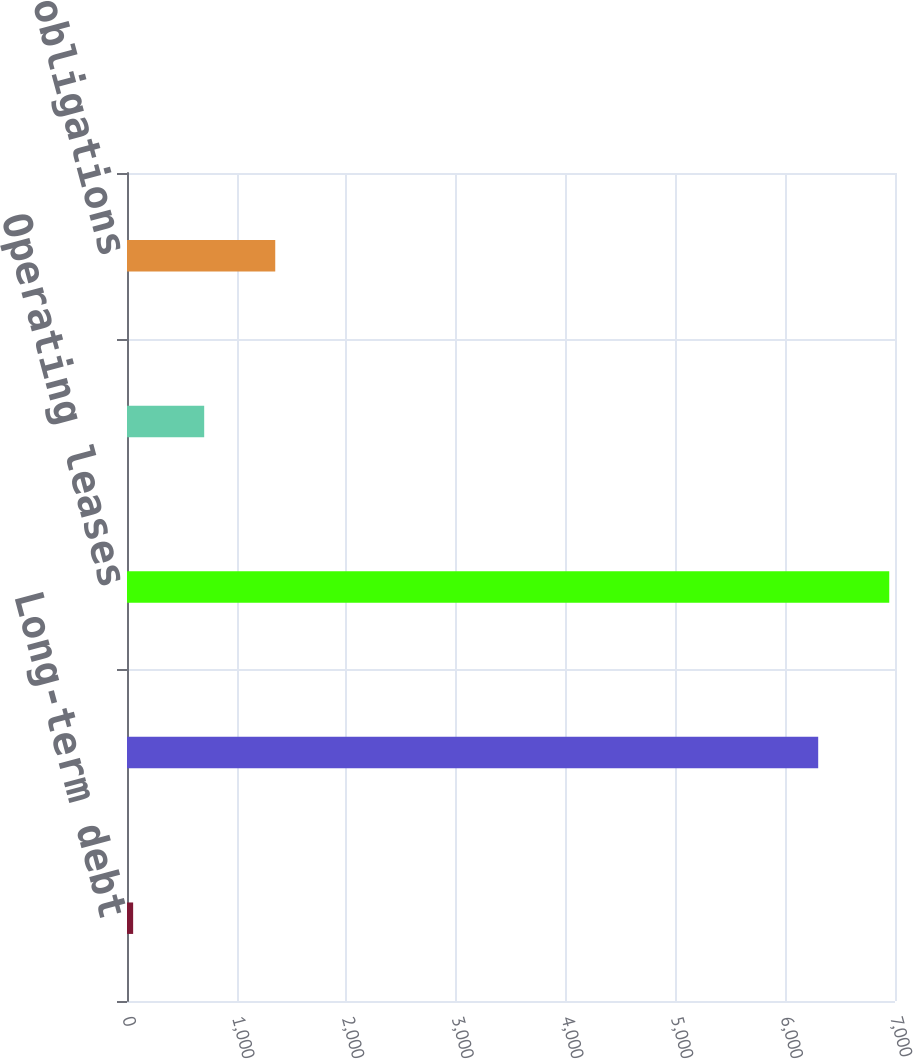Convert chart to OTSL. <chart><loc_0><loc_0><loc_500><loc_500><bar_chart><fcel>Long-term debt<fcel>Interest on long-term debt<fcel>Operating leases<fcel>Licensing rights<fcel>Post-retirement obligations<nl><fcel>56<fcel>6300<fcel>6947.6<fcel>703.6<fcel>1351.2<nl></chart> 